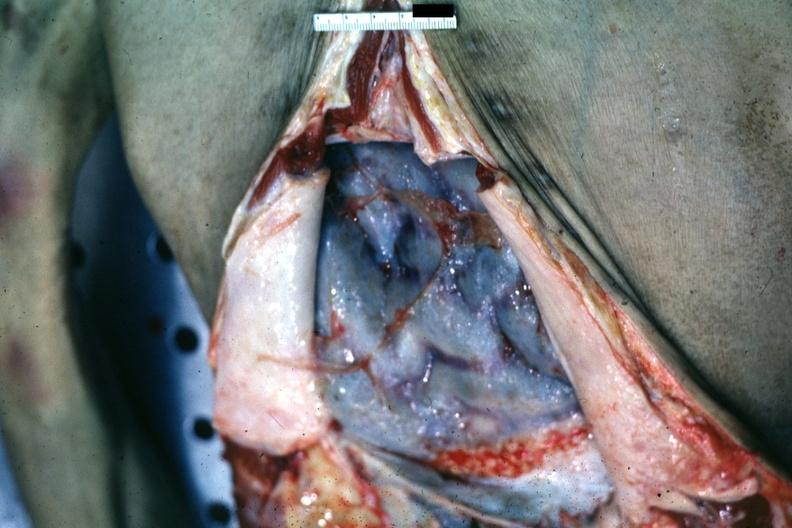where is this area in the body?
Answer the question using a single word or phrase. Abdomen 